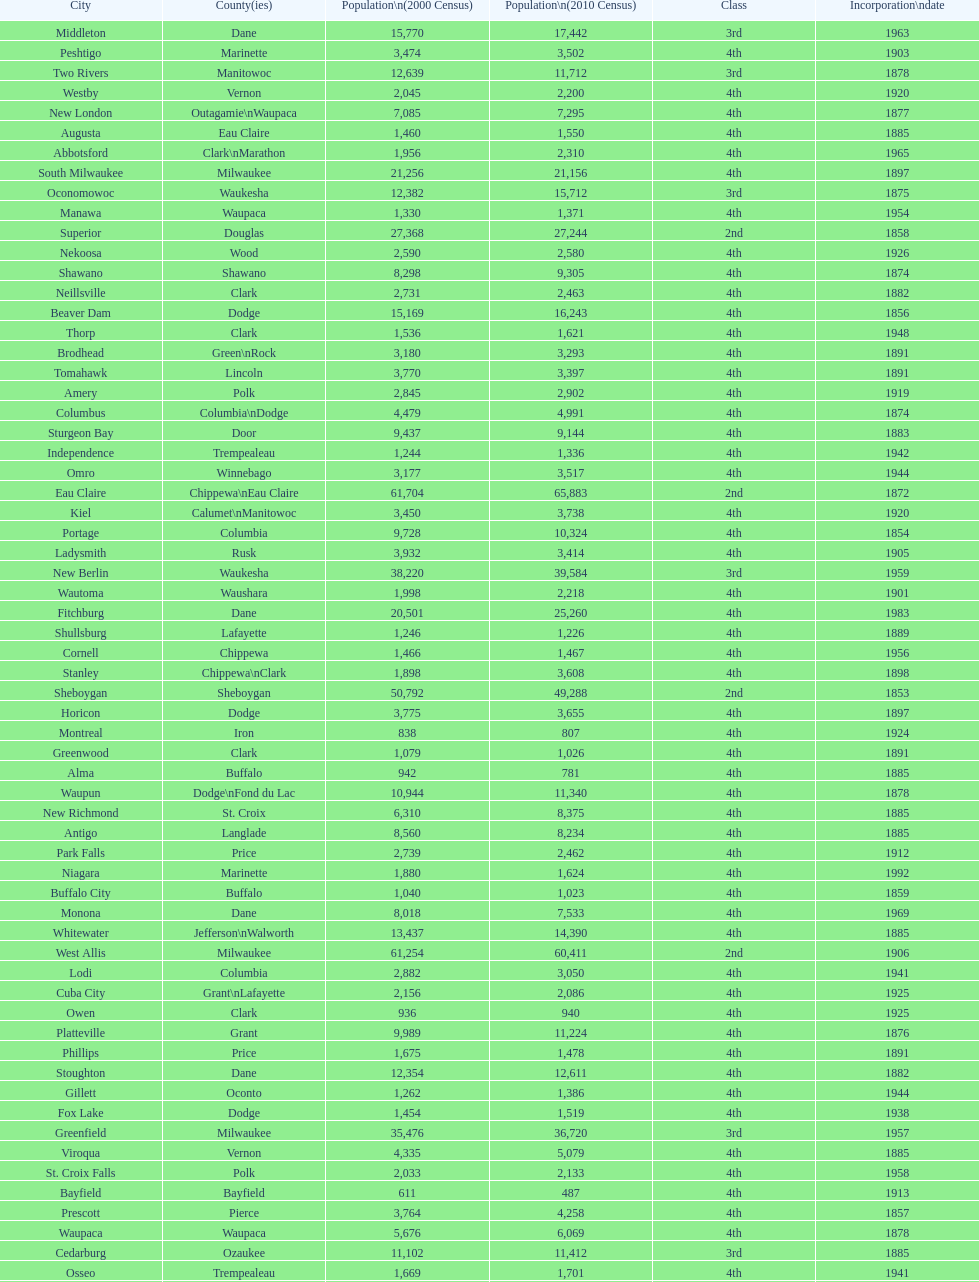Could you help me parse every detail presented in this table? {'header': ['City', 'County(ies)', 'Population\\n(2000 Census)', 'Population\\n(2010 Census)', 'Class', 'Incorporation\\ndate'], 'rows': [['Middleton', 'Dane', '15,770', '17,442', '3rd', '1963'], ['Peshtigo', 'Marinette', '3,474', '3,502', '4th', '1903'], ['Two Rivers', 'Manitowoc', '12,639', '11,712', '3rd', '1878'], ['Westby', 'Vernon', '2,045', '2,200', '4th', '1920'], ['New London', 'Outagamie\\nWaupaca', '7,085', '7,295', '4th', '1877'], ['Augusta', 'Eau Claire', '1,460', '1,550', '4th', '1885'], ['Abbotsford', 'Clark\\nMarathon', '1,956', '2,310', '4th', '1965'], ['South Milwaukee', 'Milwaukee', '21,256', '21,156', '4th', '1897'], ['Oconomowoc', 'Waukesha', '12,382', '15,712', '3rd', '1875'], ['Manawa', 'Waupaca', '1,330', '1,371', '4th', '1954'], ['Superior', 'Douglas', '27,368', '27,244', '2nd', '1858'], ['Nekoosa', 'Wood', '2,590', '2,580', '4th', '1926'], ['Shawano', 'Shawano', '8,298', '9,305', '4th', '1874'], ['Neillsville', 'Clark', '2,731', '2,463', '4th', '1882'], ['Beaver Dam', 'Dodge', '15,169', '16,243', '4th', '1856'], ['Thorp', 'Clark', '1,536', '1,621', '4th', '1948'], ['Brodhead', 'Green\\nRock', '3,180', '3,293', '4th', '1891'], ['Tomahawk', 'Lincoln', '3,770', '3,397', '4th', '1891'], ['Amery', 'Polk', '2,845', '2,902', '4th', '1919'], ['Columbus', 'Columbia\\nDodge', '4,479', '4,991', '4th', '1874'], ['Sturgeon Bay', 'Door', '9,437', '9,144', '4th', '1883'], ['Independence', 'Trempealeau', '1,244', '1,336', '4th', '1942'], ['Omro', 'Winnebago', '3,177', '3,517', '4th', '1944'], ['Eau Claire', 'Chippewa\\nEau Claire', '61,704', '65,883', '2nd', '1872'], ['Kiel', 'Calumet\\nManitowoc', '3,450', '3,738', '4th', '1920'], ['Portage', 'Columbia', '9,728', '10,324', '4th', '1854'], ['Ladysmith', 'Rusk', '3,932', '3,414', '4th', '1905'], ['New Berlin', 'Waukesha', '38,220', '39,584', '3rd', '1959'], ['Wautoma', 'Waushara', '1,998', '2,218', '4th', '1901'], ['Fitchburg', 'Dane', '20,501', '25,260', '4th', '1983'], ['Shullsburg', 'Lafayette', '1,246', '1,226', '4th', '1889'], ['Cornell', 'Chippewa', '1,466', '1,467', '4th', '1956'], ['Stanley', 'Chippewa\\nClark', '1,898', '3,608', '4th', '1898'], ['Sheboygan', 'Sheboygan', '50,792', '49,288', '2nd', '1853'], ['Horicon', 'Dodge', '3,775', '3,655', '4th', '1897'], ['Montreal', 'Iron', '838', '807', '4th', '1924'], ['Greenwood', 'Clark', '1,079', '1,026', '4th', '1891'], ['Alma', 'Buffalo', '942', '781', '4th', '1885'], ['Waupun', 'Dodge\\nFond du Lac', '10,944', '11,340', '4th', '1878'], ['New Richmond', 'St. Croix', '6,310', '8,375', '4th', '1885'], ['Antigo', 'Langlade', '8,560', '8,234', '4th', '1885'], ['Park Falls', 'Price', '2,739', '2,462', '4th', '1912'], ['Niagara', 'Marinette', '1,880', '1,624', '4th', '1992'], ['Buffalo City', 'Buffalo', '1,040', '1,023', '4th', '1859'], ['Monona', 'Dane', '8,018', '7,533', '4th', '1969'], ['Whitewater', 'Jefferson\\nWalworth', '13,437', '14,390', '4th', '1885'], ['West Allis', 'Milwaukee', '61,254', '60,411', '2nd', '1906'], ['Lodi', 'Columbia', '2,882', '3,050', '4th', '1941'], ['Cuba City', 'Grant\\nLafayette', '2,156', '2,086', '4th', '1925'], ['Owen', 'Clark', '936', '940', '4th', '1925'], ['Platteville', 'Grant', '9,989', '11,224', '4th', '1876'], ['Phillips', 'Price', '1,675', '1,478', '4th', '1891'], ['Stoughton', 'Dane', '12,354', '12,611', '4th', '1882'], ['Gillett', 'Oconto', '1,262', '1,386', '4th', '1944'], ['Fox Lake', 'Dodge', '1,454', '1,519', '4th', '1938'], ['Greenfield', 'Milwaukee', '35,476', '36,720', '3rd', '1957'], ['Viroqua', 'Vernon', '4,335', '5,079', '4th', '1885'], ['St. Croix Falls', 'Polk', '2,033', '2,133', '4th', '1958'], ['Bayfield', 'Bayfield', '611', '487', '4th', '1913'], ['Prescott', 'Pierce', '3,764', '4,258', '4th', '1857'], ['Waupaca', 'Waupaca', '5,676', '6,069', '4th', '1878'], ['Cedarburg', 'Ozaukee', '11,102', '11,412', '3rd', '1885'], ['Osseo', 'Trempealeau', '1,669', '1,701', '4th', '1941'], ['Waterloo', 'Jefferson', '3,259', '3,333', '4th', '1962'], ['Blair', 'Trempealeau', '1,273', '1,366', '4th', '1949'], ['Brillion', 'Calumet', '2,937', '3,148', '4th', '1944'], ['Lake Geneva', 'Walworth', '7,148', '7,651', '4th', '1883'], ['Rice Lake', 'Barron', '8,312', '8,438', '4th', '1887'], ['Milton', 'Rock', '5,132', '5,546', '4th', '1969'], ['Mosinee', 'Marathon', '4,063', '3,988', '4th', '1931'], ['Oconto Falls', 'Oconto', '2,843', '2,891', '4th', '1919'], ['Juneau', 'Dodge', '2,485', '2,814', '4th', '1887'], ['Fountain City', 'Buffalo', '983', '859', '4th', '1889'], ['Muskego', 'Waukesha', '21,397', '24,135', '3rd', '1964'], ['Delavan', 'Walworth', '7,956', '8,463', '4th', '1897'], ['Sheboygan Falls', 'Sheboygan', '6,772', '7,775', '4th', '1913'], ['Arcadia', 'Trempealeau', '2,402', '2,925', '4th', '1925'], ['Evansville', 'Rock', '4,039', '5,012', '4th', '1896'], ['Chilton', 'Calumet', '3,708', '3,933', '4th', '1877'], ['Stevens Point', 'Portage', '24,551', '26,717', '3rd', '1858'], ['Glendale', 'Milwaukee', '13,367', '12,872', '3rd', '1950'], ['Milwaukee', 'Milwaukee\\nWashington\\nWaukesha', '596,974', '594,833', '1st', '1846'], ['Eagle River', 'Vilas', '1,443', '1,398', '4th', '1937'], ['Edgerton', 'Dane\\nRock', '4,898', '5,461', '4th', '1883'], ['Watertown', 'Dodge\\nJefferson', '21,598', '23,861', '3rd', '1853'], ['New Holstein', 'Calumet', '3,301', '3,236', '4th', '1889'], ['Crandon', 'Forest', '1,961', '1,920', '4th', '1898'], ['Berlin', 'Green Lake\\nWaushara', '5,305', '5,524', '4th', '1857'], ['Baraboo', 'Sauk', '10,711', '12,048', '3rd', '1882'], ['Green Lake', 'Green Lake', '1,100', '960', '4th', '1962'], ['Weyauwega', 'Waupaca', '1,806', '1,900', '4th', '1939'], ['Fort Atkinson', 'Jefferson', '11,621', '12,368', '4th', '1878'], ['Appleton', 'Calumet\\nOutagamie\\nWinnebago', '70,087', '72,623', '2nd', '1857'], ['Chippewa Falls', 'Chippewa', '12,900', '13,679', '3rd', '1840'], ['St. Francis', 'Milwaukee', '8,662', '9,365', '4th', '1951'], ['Kaukauna', 'Outagamie', '12,983', '15,462', '3rd', '1885'], ['Dodgeville', 'Iowa', '4,220', '4,698', '4th', '1889'], ['Hartford', 'Dodge\\nWashington', '10,905', '14,223', '3rd', '1883'], ['Kewaunee', 'Kewaunee', '2,806', '2,952', '4th', '1883'], ['Sparta', 'Monroe', '8,648', '9,522', '4th', '1883'], ['New Lisbon', 'Juneau', '1,436', '2,554', '4th', '1889'], ['Oshkosh', 'Winnebago', '62,916', '66,083', '2nd', '1853'], ['Hillsboro', 'Vernon', '1,302', '1,417', '4th', '1885'], ['Spooner', 'Washburn', '2,653', '2,682', '4th', '1909'], ['Lake Mills', 'Jefferson', '4,843', '5,708', '4th', '1905'], ['Tomah', 'Monroe', '8,419', '9,093', '4th', '1883'], ['Durand', 'Pepin', '1,968', '1,931', '4th', '1887'], ['Marion', 'Shawano\\nWaupaca', '1,297', '1,260', '4th', '1898'], ['Hurley', 'Iron', '1,818', '1,547', '4th', '1918'], ['Bloomer', 'Chippewa', '3,347', '3,539', '4th', '1920'], ['Fennimore', 'Grant', '2,387', '2,497', '4th', '1919'], ['Port Washington', 'Ozaukee', '10,467', '11,250', '4th', '1882'], ['Lancaster', 'Grant', '4,070', '3,868', '4th', '1878'], ['Hayward', 'Sawyer', '2,129', '2,318', '4th', '1915'], ['Mineral Point', 'Iowa', '2,617', '2,487', '4th', '1857'], ['Manitowoc', 'Manitowoc', '34,053', '33,736', '3rd', '1870'], ['Sun Prairie', 'Dane', '20,369', '29,364', '3rd', '1958'], ['River Falls', 'Pierce\\nSt. Croix', '12,560', '15,000', '3rd', '1875'], ['Schofield', 'Marathon', '2,117', '2,169', '4th', '1951'], ['Monroe', 'Green', '10,843', '10,827', '4th', '1882'], ['Markesan', 'Green Lake', '1,396', '1,476', '4th', '1959'], ['Mellen', 'Ashland', '845', '731', '4th', '1907'], ['Marinette', 'Marinette', '11,749', '10,968', '3rd', '1887'], ['Fond du Lac', 'Fond du Lac', '42,203', '43,021', '2nd', '1852'], ['La Crosse', 'La Crosse', '51,818', '51,320', '2nd', '1856'], ['Cumberland', 'Barron', '2,280', '2,170', '4th', '1885'], ['Medford', 'Taylor', '4,350', '4,326', '4th', '1889'], ['Whitehall', 'Trempealeau', '1,651', '1,558', '4th', '1941'], ['Hudson', 'St. Croix', '8,775', '12,719', '4th', '1858'], ['Clintonville', 'Waupaca', '4,736', '4,559', '4th', '1887'], ['Loyal', 'Clark', '1,308', '1,261', '4th', '1948'], ['Marshfield', 'Marathon\\nWood', '18,800', '19,118', '3rd', '1883'], ['Verona', 'Dane', '7,052', '10,619', '4th', '1977'], ['Glenwood City', 'St. Croix', '1,183', '1,242', '4th', '1895'], ['Shell Lake', 'Washburn', '1,309', '1,347', '4th', '1961'], ['Princeton', 'Green Lake', '1,504', '1,214', '4th', '1920'], ['Racine', 'Racine', '81,855', '78,860', '2nd', '1848'], ['Elkhorn', 'Walworth', '7,305', '10,084', '4th', '1897'], ['Wauwatosa', 'Milwaukee', '47,271', '46,396', '2nd', '1897'], ['Chetek', 'Barron', '2,180', '2,221', '4th', '1891'], ['Green Bay', 'Brown', '102,767', '104,057', '2nd', '1854'], ['Pewaukee', 'Waukesha', '11,783', '13,195', '3rd', '1999'], ['Black River Falls', 'Jackson', '3,618', '3,622', '4th', '1883'], ['Menomonie', 'Dunn', '14,937', '16,264', '4th', '1882'], ['Oak Creek', 'Milwaukee', '28,456', '34,451', '3rd', '1955'], ['Ashland', 'Ashland\\nBayfield', '8,620', '8,216', '4th', '1887'], ['Colby', 'Clark\\nMarathon', '1,616', '1,852', '4th', '1891'], ['West Bend', 'Washington', '28,152', '31,078', '3rd', '1885'], ['Mauston', 'Juneau', '3,740', '4,423', '4th', '1883'], ['Menasha', 'Calumet\\nWinnebago', '16,331', '17,353', '3rd', '1874'], ['Barron', 'Barron', '3,248', '3,423', '4th', '1887'], ['Reedsburg', 'Sauk', '7,827', '10,014', '4th', '1887'], ['De Pere', 'Brown', '20,559', '23,800', '3rd', '1883'], ['Jefferson', 'Jefferson', '7,338', '7,973', '4th', '1878'], ['Wisconsin Dells', 'Adams\\nColumbia\\nJuneau\\nSauk', '2,418', '2,678', '4th', '1925'], ['Franklin', 'Milwaukee', '29,494', '35,451', '3rd', '1956'], ['Pittsville', 'Wood', '866', '874', '4th', '1887'], ['Montello', 'Marquette', '1,397', '1,495', '4th', '1938'], ['Beloit', 'Rock', '35,775', '36,966', '3rd', '1857'], ['Neenah', 'Winnebago', '24,507', '25,501', '3rd', '1873'], ['Madison', 'Dane', '208,054', '233,209', '2nd', '1856'], ['Cudahy', 'Milwaukee', '18,429', '18,267', '3rd', '1906'], ['Seymour', 'Outagamie', '3,335', '3,451', '4th', '1879'], ['Galesville', 'Trempealeau', '1,427', '1,481', '4th', '1942'], ['Adams', 'Adams', '1,831', '1,967', '4th', '1926'], ['Mondovi', 'Buffalo', '2,634', '2,777', '4th', '1889'], ['Mequon', 'Ozaukee', '22,643', '23,132', '4th', '1957'], ['Rhinelander', 'Oneida', '7,735', '7,798', '4th', '1894'], ['Elroy', 'Juneau', '1,578', '1,442', '4th', '1885'], ['Prairie du Chien', 'Crawford', '6,018', '5,911', '4th', '1872'], ['Washburn', 'Bayfield', '2,280', '2,117', '4th', '1904'], ['Waukesha', 'Waukesha', '64,825', '70,718', '2nd', '1895'], ['Richland Center', 'Richland', '5,114', '5,184', '4th', '1887'], ['Mayville', 'Dodge', '4,902', '5,154', '4th', '1885'], ['Wisconsin Rapids', 'Wood', '18,435', '18,367', '3rd', '1869'], ['Merrill', 'Lincoln', '10,146', '9,661', '4th', '1883'], ['Oconto', 'Oconto', '4,708', '4,513', '4th', '1869'], ['Ripon', 'Fond du Lac', '7,450', '7,733', '4th', '1858'], ['Onalaska', 'La Crosse', '14,839', '17,736', '4th', '1887'], ['Delafield', 'Waukesha', '6,472', '7,085', '4th', '1959'], ['Brookfield', 'Waukesha', '38,649', '37,920', '2nd', '1954'], ['Boscobel', 'Grant', '3,047', '3,231', '4th', '1873'], ['Plymouth', 'Sheboygan', '7,781', '8,445', '4th', '1877'], ['Janesville', 'Rock', '59,498', '63,575', '2nd', '1853'], ['Wausau', 'Marathon', '38,426', '39,106', '3rd', '1872'], ['Altoona', 'Eau Claire', '6,698', '6,706', '4th', '1887'], ['Darlington', 'Lafayette', '2,418', '2,451', '4th', '1877'], ['Burlington', 'Racine\\nWalworth', '9,936', '10,464', '4th', '1900'], ['Kenosha', 'Kenosha', '90,352', '99,218', '2nd', '1850'], ['Algoma', 'Kewaunee', '3,357', '3,167', '4th', '1879']]} Which city in wisconsin is the most populous, based on the 2010 census? Milwaukee. 